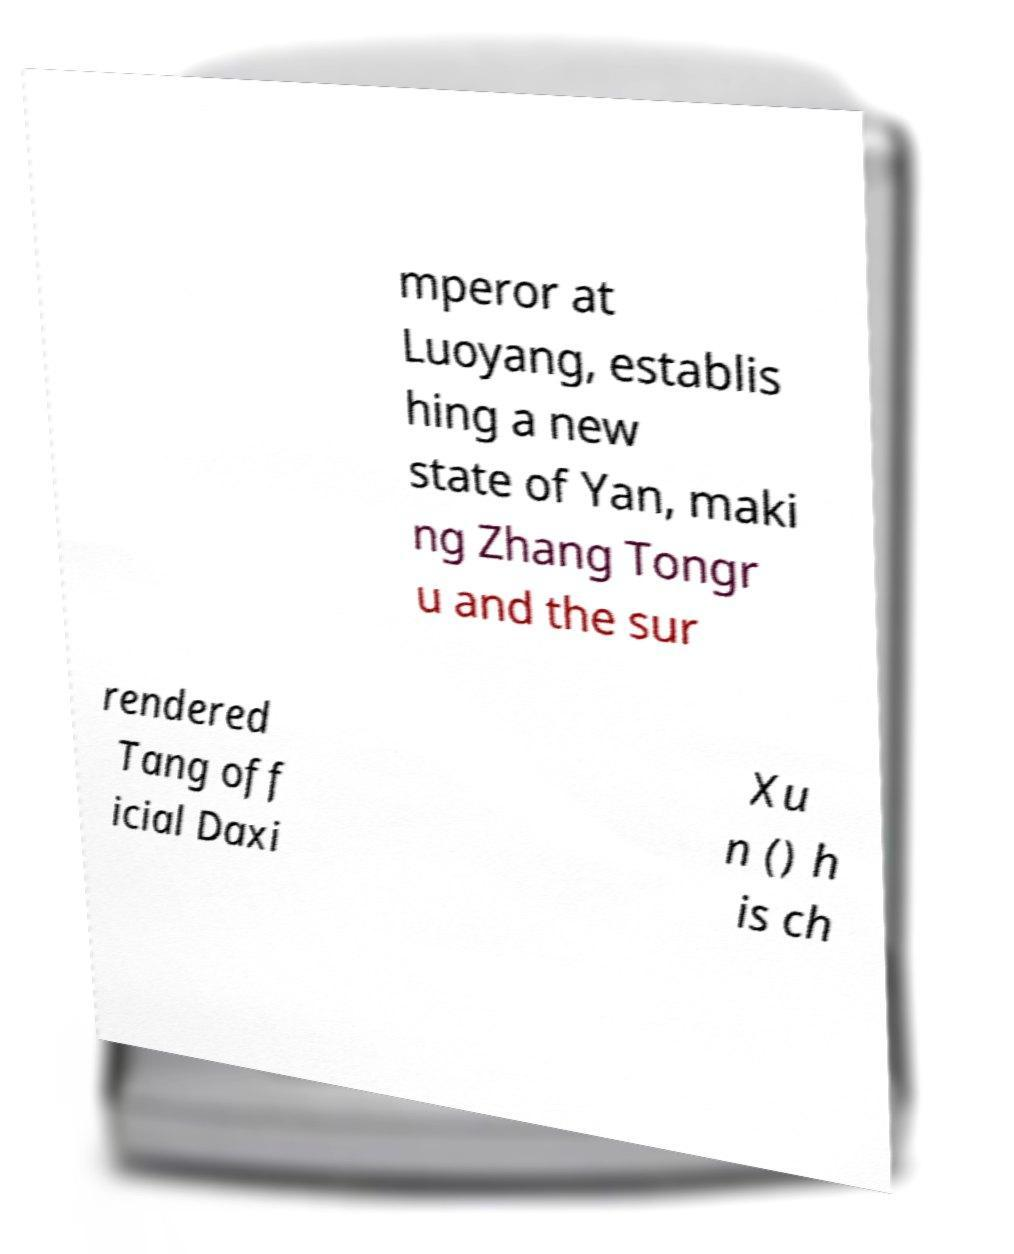Could you assist in decoding the text presented in this image and type it out clearly? mperor at Luoyang, establis hing a new state of Yan, maki ng Zhang Tongr u and the sur rendered Tang off icial Daxi Xu n () h is ch 